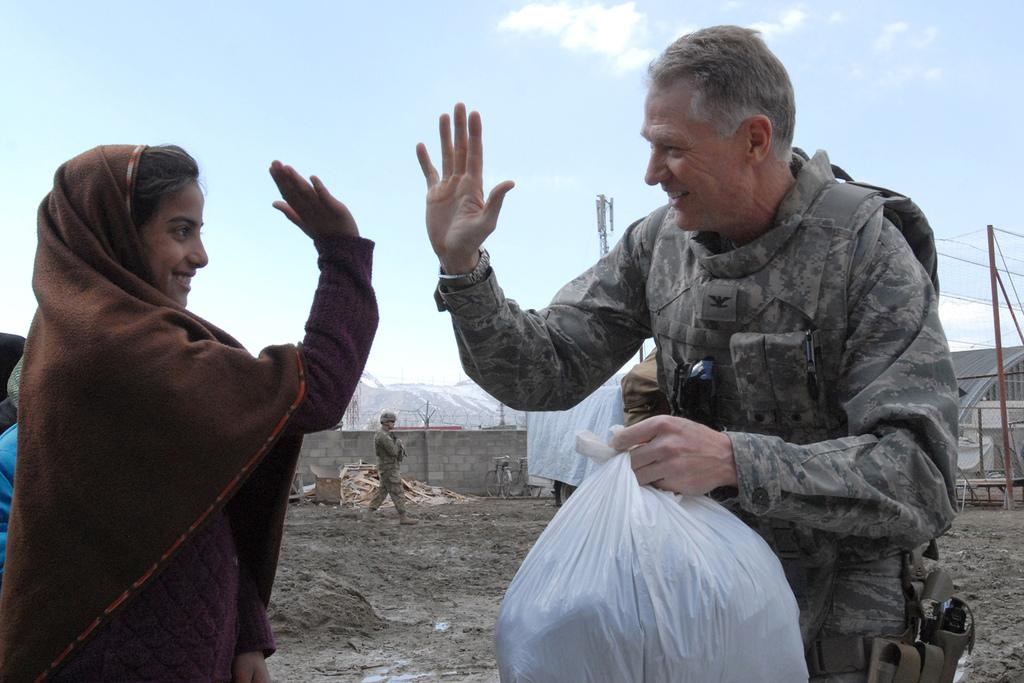Who are the people in the image? There is a man and a woman in the image, and another man. What are the man and woman doing? The man and woman are giving a high five. What is the man carrying? The man is carrying a carry bag. What is the other man doing? The other man is walking. How would you describe the sky in the image? The sky is blue and cloudy. What type of religious ceremony is taking place in the image? There is no indication of a religious ceremony in the image; it features a man and a woman giving a high five, a man carrying a bag, and another man walking. How many soldiers are present in the image? There are no soldiers present in the image. 